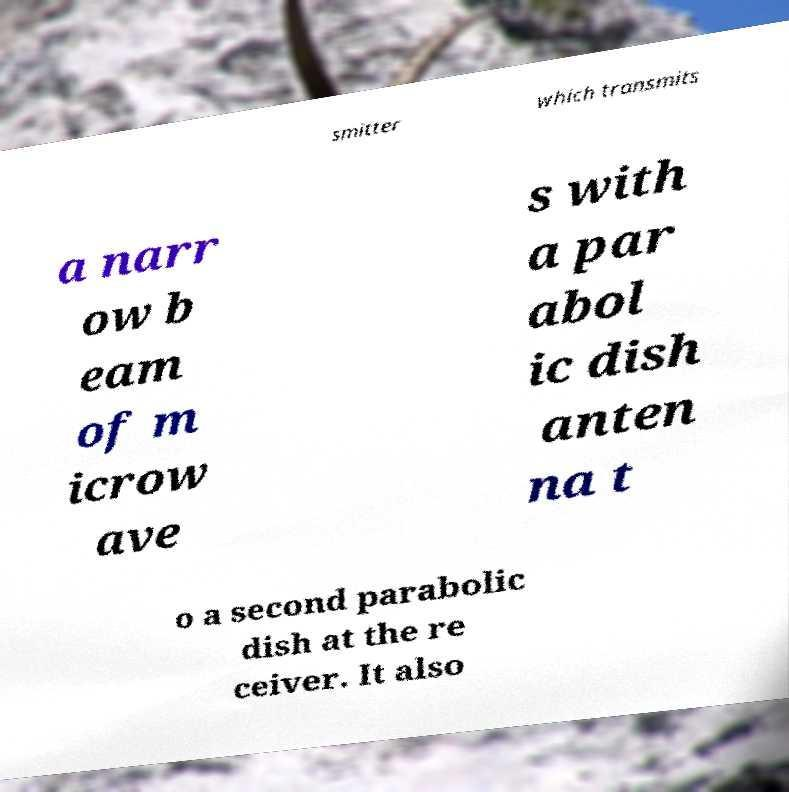I need the written content from this picture converted into text. Can you do that? smitter which transmits a narr ow b eam of m icrow ave s with a par abol ic dish anten na t o a second parabolic dish at the re ceiver. It also 